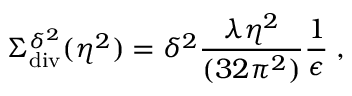<formula> <loc_0><loc_0><loc_500><loc_500>\Sigma _ { d i v } ^ { \delta ^ { 2 } } ( \eta ^ { 2 } ) = \delta ^ { 2 } \frac { \lambda \eta ^ { 2 } } { ( 3 2 \pi ^ { 2 } ) } \frac { 1 } { \epsilon } \, ,</formula> 